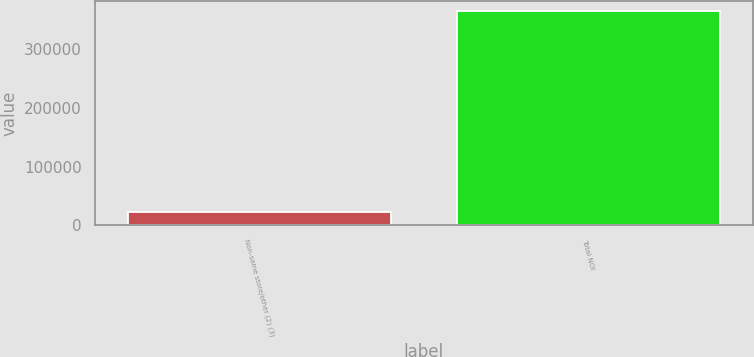Convert chart. <chart><loc_0><loc_0><loc_500><loc_500><bar_chart><fcel>Non-same store/other (2) (3)<fcel>Total NOI<nl><fcel>22677<fcel>363935<nl></chart> 